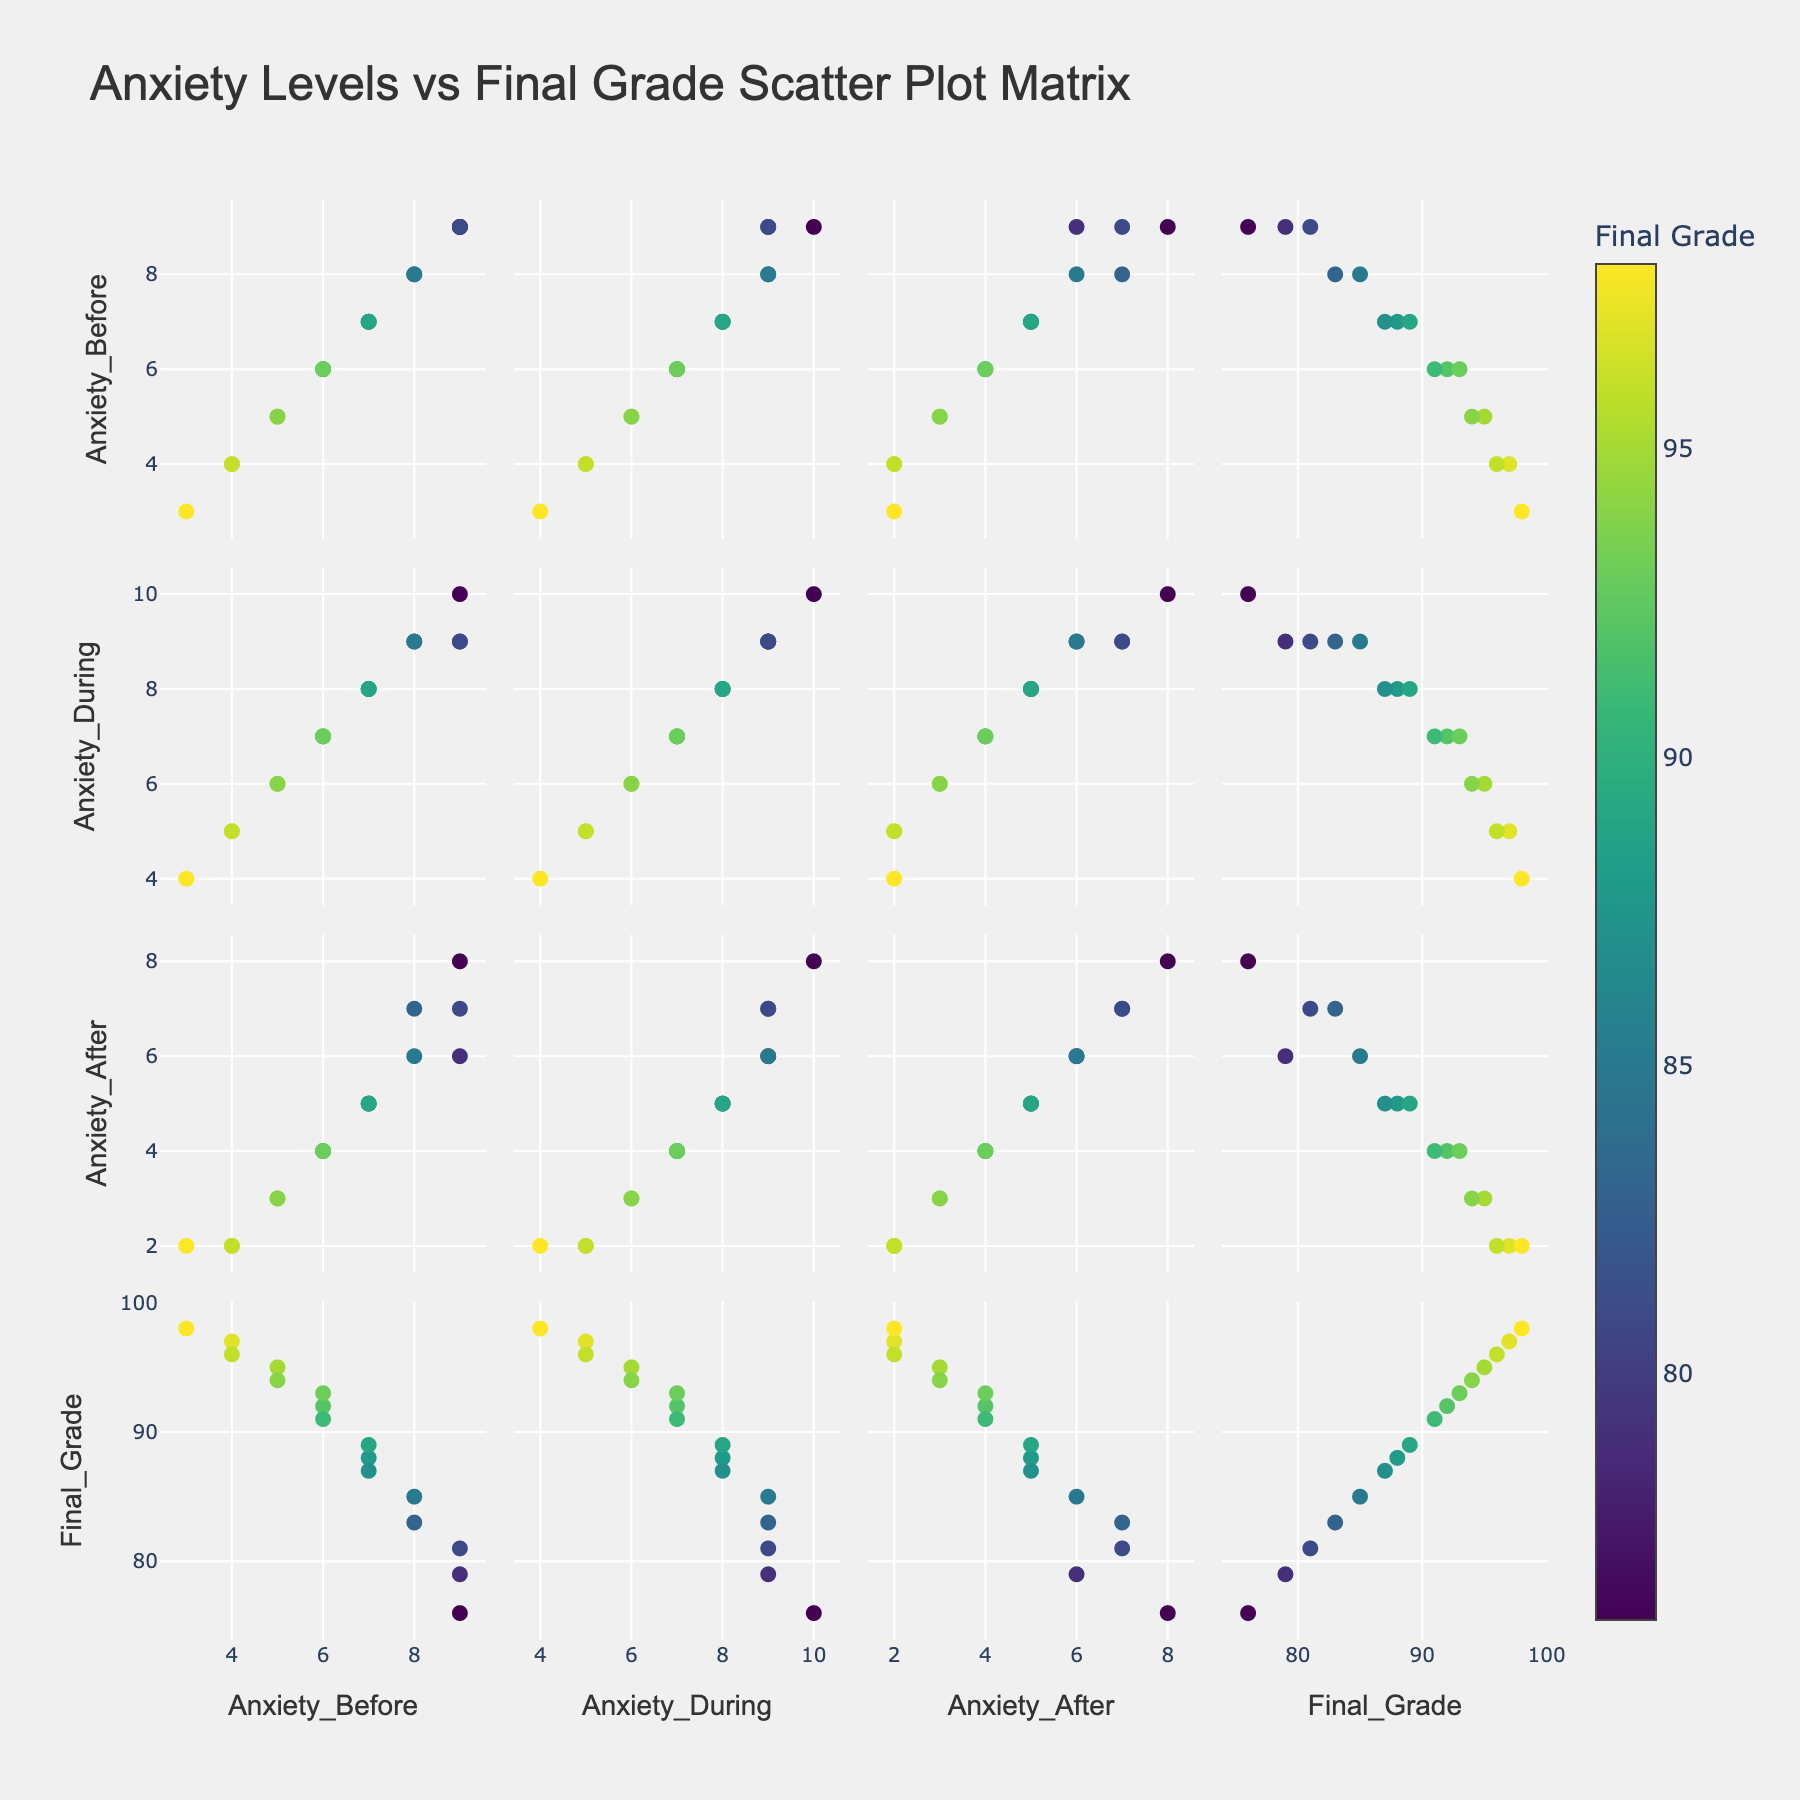Which variable seems to have more variability among the students, Anxiety_Before or Anxiety_After? By comparing the scatterplots for Anxiety_Before and Anxiety_After against the other variables, it appears that Anxiety_After shows a wider range of values on the y-axis. This indicates more variability.
Answer: Anxiety_After How does the Final_Grade correlate with Anxiety_During the exam? Look at the scatter plots where Final_Grade is on one axis and Anxiety_During is on the other. The general trend should indicate whether an increase in Anxiety_During corresponds to higher or lower grades. The figure shows that higher anxiety during the exam tends to correspond with lower final grades.
Answer: Negatively Among all students, who had the lowest Anxiety_After but did not achieve the highest Final_Grade? Check the scatter plot with Anxiety_After on one axis and Final_Grade on the other. Find the point with the lowest Anxiety_After that does not coincide with the highest Final_Grade. Ethan had the lowest Anxiety_After (2), but his Final_Grade was 97, not the highest.
Answer: Ethan Is there any student who had the same anxiety levels before, during, and after exams? Observe the scatterplot matrix and look for overlapping points along the diagonal lines where Anxiety_Before, Anxiety_During, and Anxiety_After intersect. There are no points where Before, During, and After anxiety levels are the same.
Answer: No Which variable has the strongest correlation with the final grade? Compare the scatterplots where Final_Grade is on one axis and Anxiety_Before, Anxiety_During, and Anxiety_After are on the other. The variable with the most defined trend line has the strongest correlation. Anxiety_After appears to show the strongest trend.
Answer: Anxiety_Before 